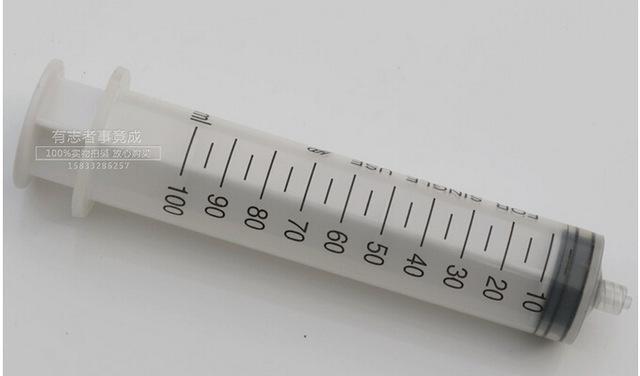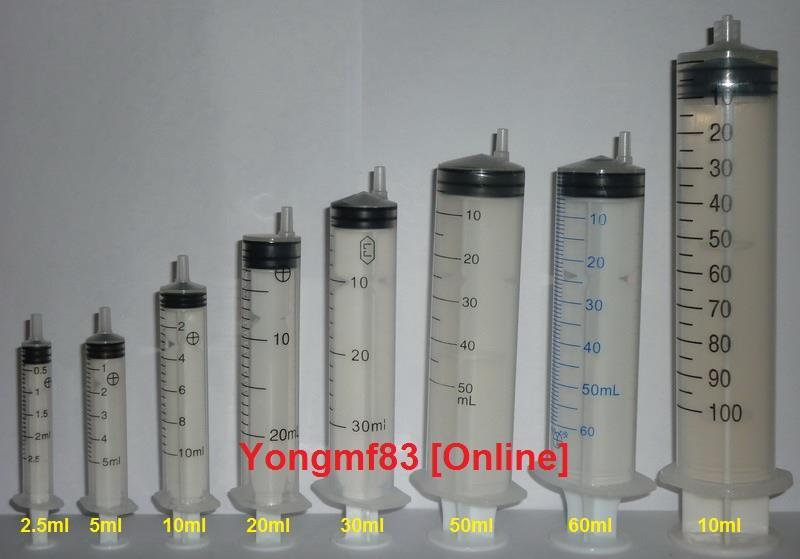The first image is the image on the left, the second image is the image on the right. Examine the images to the left and right. Is the description "One of the images shows only one syringe, and it has a ring on the end of it." accurate? Answer yes or no. No. The first image is the image on the left, the second image is the image on the right. Examine the images to the left and right. Is the description "In at least one image there are at least five syringes with one having a circle that is used to press the liquid out." accurate? Answer yes or no. No. 